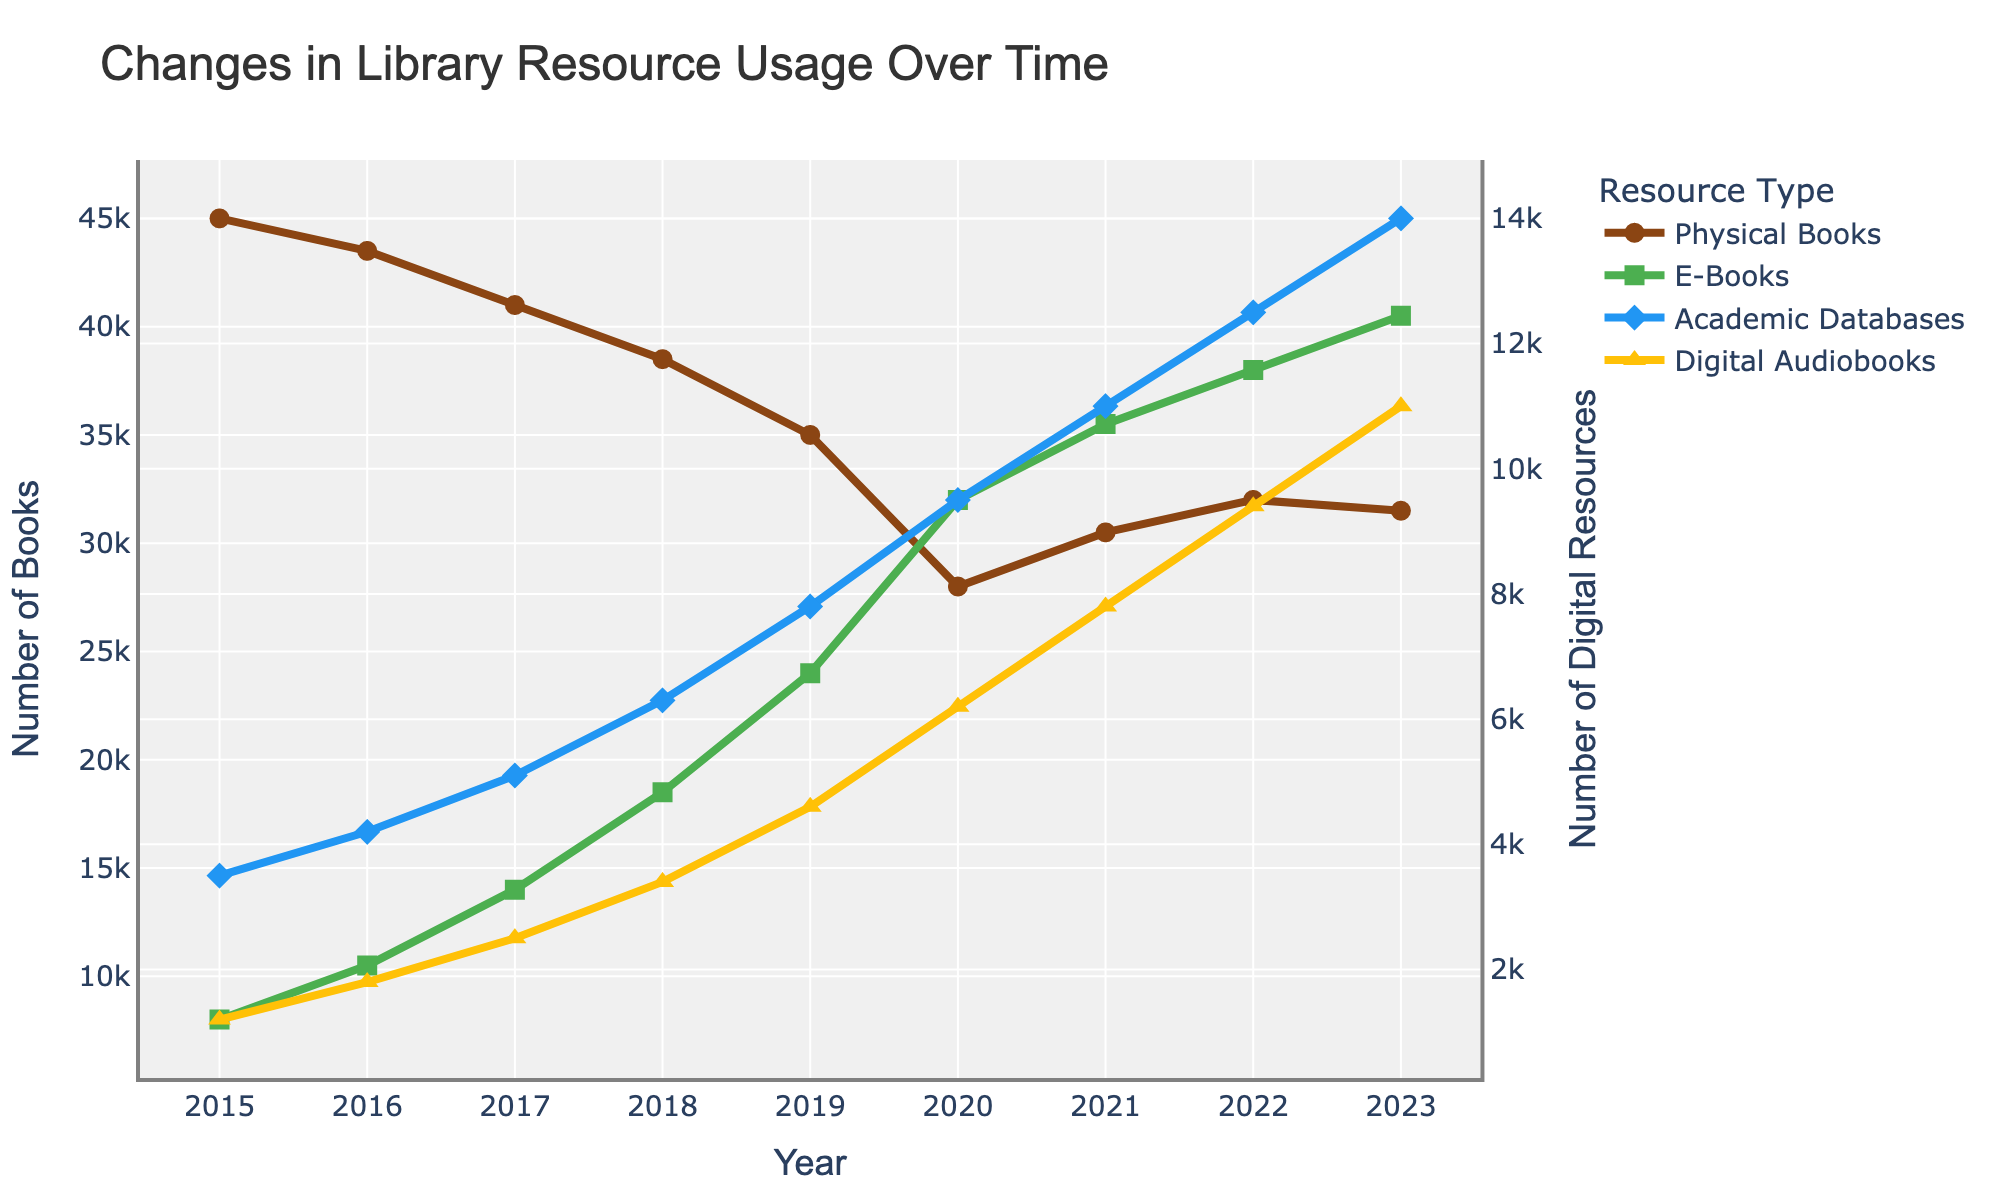How did the usage of physical books change from 2015 to 2023? Compare the number of physical books in 2015 (45000) and in 2023 (31500). Subtract the latter from the former: 45000 - 31500.
Answer: The usage of physical books decreased by 13500 What trend do you observe in the usage of E-Books from 2015 to 2023? Look at the E-Books data points from 2015 (8000) to 2023 (40500) on the graph. Observe that the usage of E-Books consistently increases each year.
Answer: The usage of E-Books consistently increased Which year saw the highest usage of digital resources across all categories? Compare the individual data points for each category (E-Books, Academic Databases, Digital Audiobooks) for each year and sum them up. Identify the year with the highest sum.
Answer: 2023 saw the highest usage of digital resources across all categories What is the percentage increase in the use of Academic Databases from 2015 to 2023? Calculate the difference between 2023 (14000) and 2015 (3500), then divide by the 2015 value and multiply by 100: ((14000 - 3500) / 3500) * 100.
Answer: The percentage increase is 300% By how much did the use of Digital Audiobooks increase from 2016 to 2022? Compare the usage data of Digital Audiobooks in 2016 (1800) and 2022 (9400). Subtract the former from the latter: 9400 - 1800.
Answer: The use of Digital Audiobooks increased by 7600 Which resource type saw the greatest increase in usage from 2015 to 2023? Calculate the increase for each resource by subtracting the 2015 value from the 2023 value: E-Books (40500 - 8000), Academic Databases (14000 - 3500), Digital Audiobooks (11000 - 1200), and Physical Books (31500 - 45000). Identify the largest increase.
Answer: E-Books saw the greatest increase in usage In which year did the use of Digital Audiobooks surpass the use of Academic Databases? Check the crossover point on the graph where Digital Audiobooks' values surpass Academic Databases' values. Identify the year.
Answer: 2017 How does the change in usage of Physical Books compare to that of E-Books from 2015 to 2023? Calculate the change for Physical Books (45000 - 31500) and E-Books (40500 - 8000). Compare the magnitude and direction of the changes.
Answer: Physical Books decreased by 13500, while E-Books increased by 32500 Which resource type had the lowest usage in 2015, and what was it? Look at the data for 2015 and identify the lowest usage value among all resources.
Answer: Digital Audiobooks had the lowest usage in 2015, with 1200 What was the combined usage of Academic Databases and Digital Audiobooks in 2020? Add the values for Academic Databases (9500) and Digital Audiobooks (6200) in 2020: 9500 + 6200.
Answer: The combined usage was 15700 